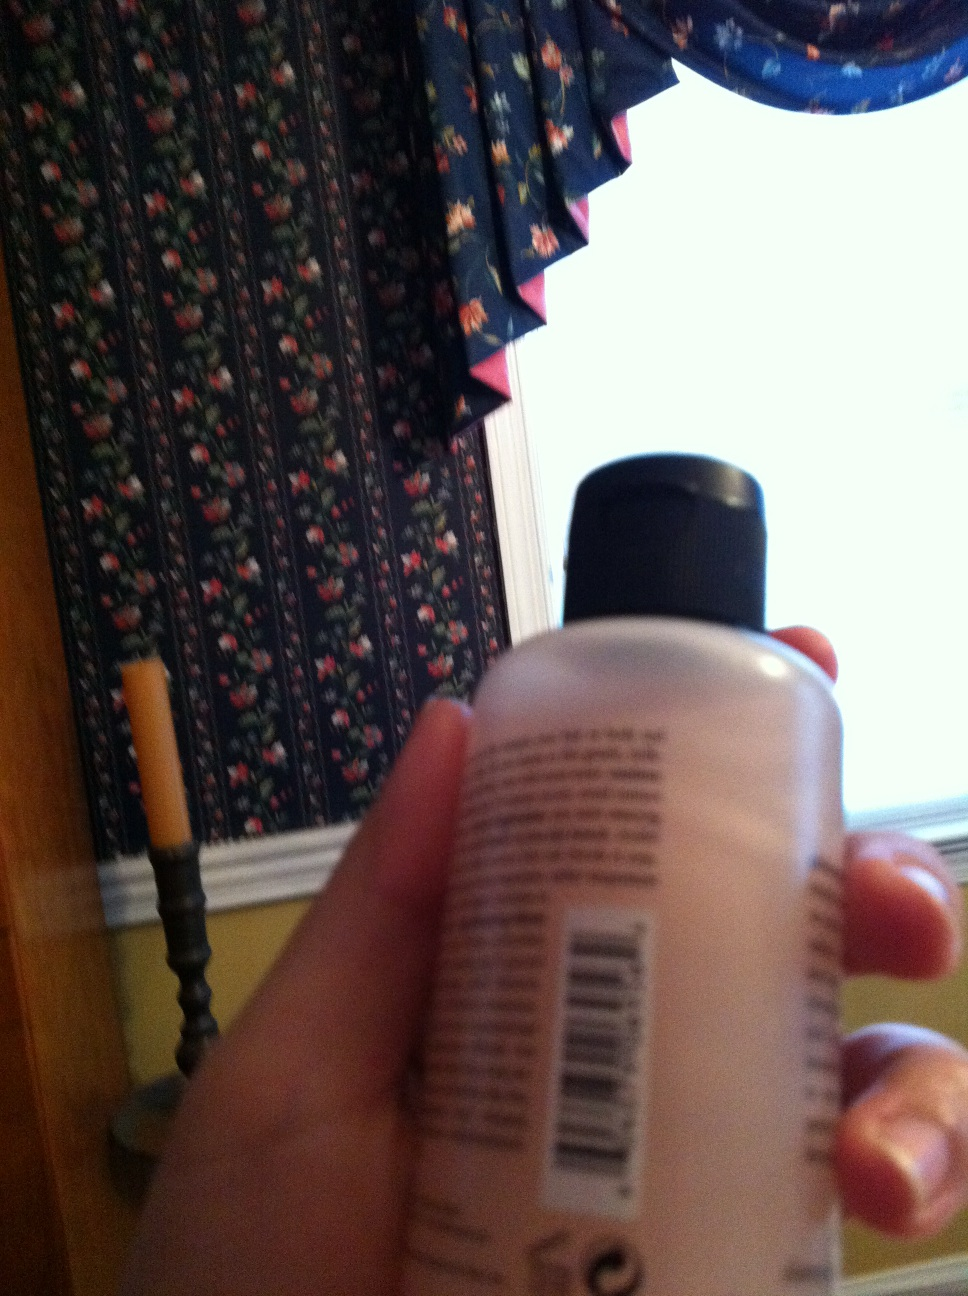Imagine a realistic scenario related to the object in the image. In a realistic scenario, the person holding the bottle might be getting ready for the day or wrapping up their nighttime skincare routine. They are likely to apply the lotion after washing their hands or face, ensuring their skin stays moisturized, especially during dry weather. 